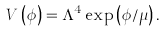Convert formula to latex. <formula><loc_0><loc_0><loc_500><loc_500>V \left ( \phi \right ) = \Lambda ^ { 4 } \exp \left ( \phi / \mu \right ) .</formula> 